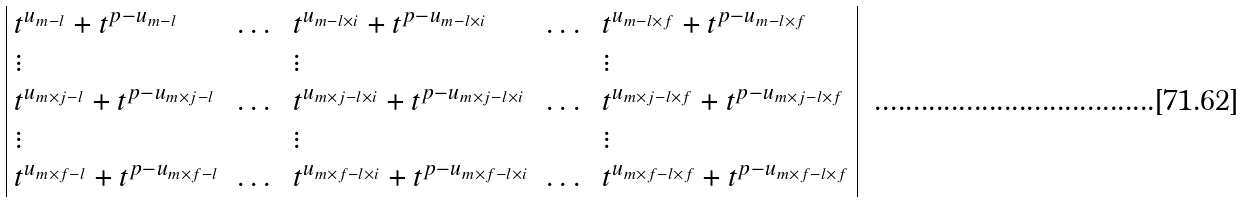Convert formula to latex. <formula><loc_0><loc_0><loc_500><loc_500>\begin{array} { | l l l l l | } t ^ { u _ { m - l } } + t ^ { p - u _ { m - l } } & \dots & t ^ { u _ { m - l \times i } } + t ^ { p - u _ { m - l \times i } } & \dots & t ^ { u _ { m - l \times f } } + t ^ { p - u _ { m - l \times f } } \\ \vdots & & \vdots & & \vdots \\ t ^ { u _ { m \times j - l } } + t ^ { p - u _ { m \times j - l } } & \dots & t ^ { u _ { m \times j - l \times i } } + t ^ { p - u _ { m \times j - l \times i } } & \dots & t ^ { u _ { m \times j - l \times f } } + t ^ { p - u _ { m \times j - l \times f } } \\ \vdots & & \vdots & & \vdots \\ t ^ { u _ { m \times f - l } } + t ^ { p - u _ { m \times f - l } } & \dots & t ^ { u _ { m \times f - l \times i } } + t ^ { p - u _ { m \times f - l \times i } } & \dots & t ^ { u _ { m \times f - l \times f } } + t ^ { p - u _ { m \times f - l \times f } } \\ \end{array}</formula> 